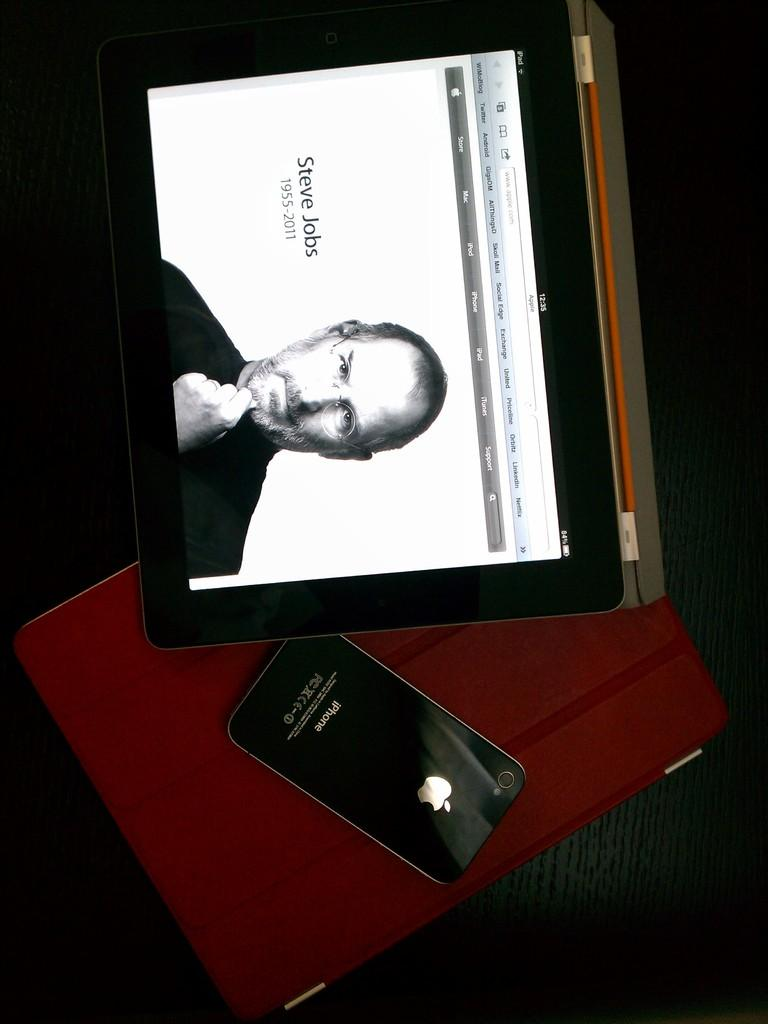<image>
Share a concise interpretation of the image provided. A tablet and a black iPhone with the apple trademark on it. 